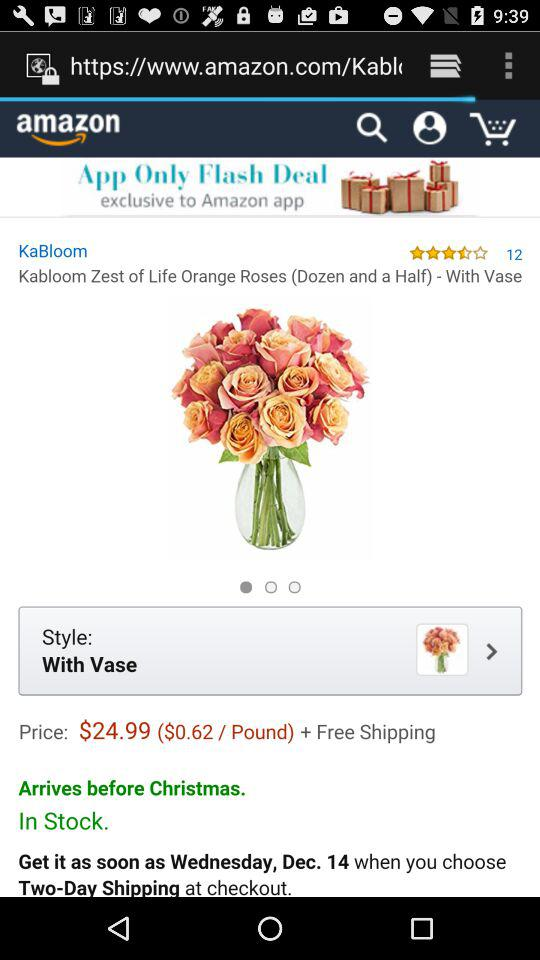What is the price? The price is $24.99. 